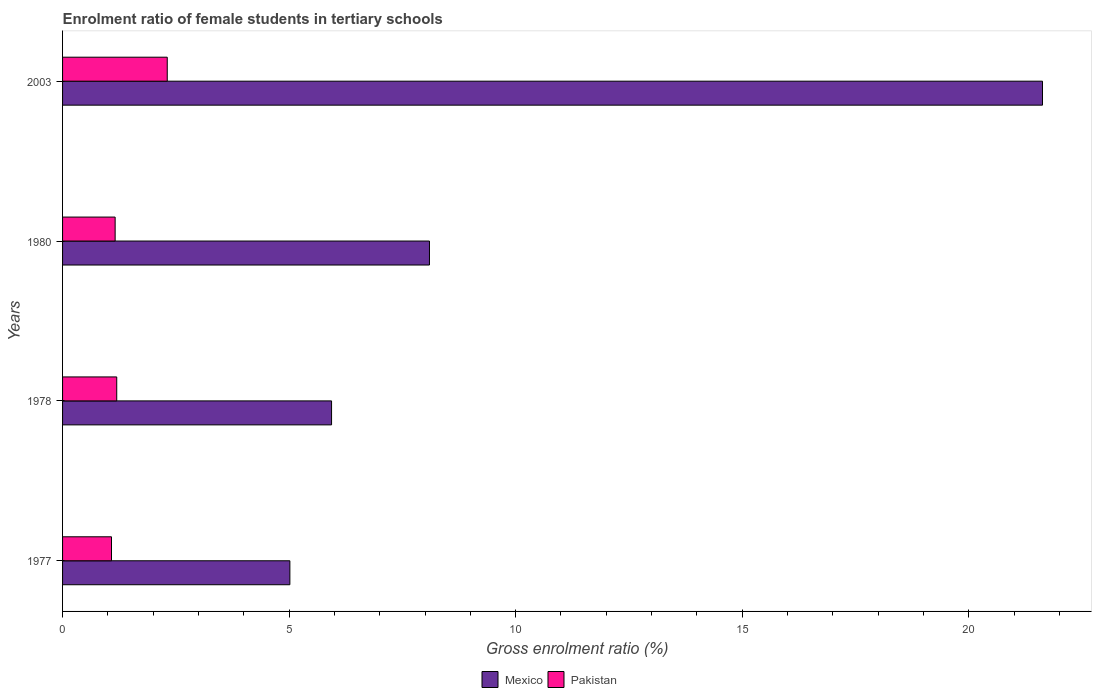How many different coloured bars are there?
Your response must be concise. 2. Are the number of bars per tick equal to the number of legend labels?
Offer a very short reply. Yes. How many bars are there on the 2nd tick from the top?
Make the answer very short. 2. How many bars are there on the 4th tick from the bottom?
Ensure brevity in your answer.  2. What is the label of the 3rd group of bars from the top?
Your response must be concise. 1978. In how many cases, is the number of bars for a given year not equal to the number of legend labels?
Your answer should be compact. 0. What is the enrolment ratio of female students in tertiary schools in Pakistan in 1978?
Make the answer very short. 1.2. Across all years, what is the maximum enrolment ratio of female students in tertiary schools in Mexico?
Make the answer very short. 21.63. What is the total enrolment ratio of female students in tertiary schools in Mexico in the graph?
Give a very brief answer. 40.68. What is the difference between the enrolment ratio of female students in tertiary schools in Pakistan in 1977 and that in 1980?
Your answer should be very brief. -0.08. What is the difference between the enrolment ratio of female students in tertiary schools in Pakistan in 1980 and the enrolment ratio of female students in tertiary schools in Mexico in 2003?
Offer a terse response. -20.47. What is the average enrolment ratio of female students in tertiary schools in Pakistan per year?
Provide a succinct answer. 1.44. In the year 2003, what is the difference between the enrolment ratio of female students in tertiary schools in Pakistan and enrolment ratio of female students in tertiary schools in Mexico?
Offer a very short reply. -19.32. What is the ratio of the enrolment ratio of female students in tertiary schools in Pakistan in 1980 to that in 2003?
Keep it short and to the point. 0.5. What is the difference between the highest and the second highest enrolment ratio of female students in tertiary schools in Mexico?
Offer a terse response. 13.53. What is the difference between the highest and the lowest enrolment ratio of female students in tertiary schools in Pakistan?
Your answer should be compact. 1.23. In how many years, is the enrolment ratio of female students in tertiary schools in Mexico greater than the average enrolment ratio of female students in tertiary schools in Mexico taken over all years?
Give a very brief answer. 1. Is the sum of the enrolment ratio of female students in tertiary schools in Pakistan in 1977 and 1980 greater than the maximum enrolment ratio of female students in tertiary schools in Mexico across all years?
Ensure brevity in your answer.  No. What does the 2nd bar from the top in 1978 represents?
Give a very brief answer. Mexico. What does the 2nd bar from the bottom in 1977 represents?
Your response must be concise. Pakistan. How many bars are there?
Provide a short and direct response. 8. How many years are there in the graph?
Make the answer very short. 4. What is the difference between two consecutive major ticks on the X-axis?
Give a very brief answer. 5. Are the values on the major ticks of X-axis written in scientific E-notation?
Your answer should be very brief. No. Does the graph contain any zero values?
Ensure brevity in your answer.  No. Where does the legend appear in the graph?
Keep it short and to the point. Bottom center. How many legend labels are there?
Your answer should be very brief. 2. How are the legend labels stacked?
Give a very brief answer. Horizontal. What is the title of the graph?
Your answer should be very brief. Enrolment ratio of female students in tertiary schools. What is the label or title of the Y-axis?
Your response must be concise. Years. What is the Gross enrolment ratio (%) in Mexico in 1977?
Provide a short and direct response. 5.02. What is the Gross enrolment ratio (%) in Mexico in 1978?
Ensure brevity in your answer.  5.94. What is the Gross enrolment ratio (%) of Pakistan in 1978?
Your response must be concise. 1.2. What is the Gross enrolment ratio (%) of Mexico in 1980?
Your answer should be very brief. 8.1. What is the Gross enrolment ratio (%) of Pakistan in 1980?
Give a very brief answer. 1.16. What is the Gross enrolment ratio (%) in Mexico in 2003?
Your response must be concise. 21.63. What is the Gross enrolment ratio (%) in Pakistan in 2003?
Your answer should be very brief. 2.31. Across all years, what is the maximum Gross enrolment ratio (%) of Mexico?
Your answer should be compact. 21.63. Across all years, what is the maximum Gross enrolment ratio (%) in Pakistan?
Offer a terse response. 2.31. Across all years, what is the minimum Gross enrolment ratio (%) in Mexico?
Give a very brief answer. 5.02. What is the total Gross enrolment ratio (%) of Mexico in the graph?
Offer a very short reply. 40.68. What is the total Gross enrolment ratio (%) of Pakistan in the graph?
Ensure brevity in your answer.  5.75. What is the difference between the Gross enrolment ratio (%) in Mexico in 1977 and that in 1978?
Make the answer very short. -0.92. What is the difference between the Gross enrolment ratio (%) of Pakistan in 1977 and that in 1978?
Keep it short and to the point. -0.12. What is the difference between the Gross enrolment ratio (%) of Mexico in 1977 and that in 1980?
Keep it short and to the point. -3.08. What is the difference between the Gross enrolment ratio (%) in Pakistan in 1977 and that in 1980?
Offer a terse response. -0.08. What is the difference between the Gross enrolment ratio (%) in Mexico in 1977 and that in 2003?
Ensure brevity in your answer.  -16.61. What is the difference between the Gross enrolment ratio (%) in Pakistan in 1977 and that in 2003?
Your answer should be very brief. -1.23. What is the difference between the Gross enrolment ratio (%) of Mexico in 1978 and that in 1980?
Offer a very short reply. -2.16. What is the difference between the Gross enrolment ratio (%) of Pakistan in 1978 and that in 1980?
Provide a succinct answer. 0.04. What is the difference between the Gross enrolment ratio (%) in Mexico in 1978 and that in 2003?
Provide a succinct answer. -15.69. What is the difference between the Gross enrolment ratio (%) in Pakistan in 1978 and that in 2003?
Your answer should be compact. -1.11. What is the difference between the Gross enrolment ratio (%) of Mexico in 1980 and that in 2003?
Keep it short and to the point. -13.53. What is the difference between the Gross enrolment ratio (%) of Pakistan in 1980 and that in 2003?
Keep it short and to the point. -1.15. What is the difference between the Gross enrolment ratio (%) of Mexico in 1977 and the Gross enrolment ratio (%) of Pakistan in 1978?
Offer a terse response. 3.82. What is the difference between the Gross enrolment ratio (%) in Mexico in 1977 and the Gross enrolment ratio (%) in Pakistan in 1980?
Provide a short and direct response. 3.86. What is the difference between the Gross enrolment ratio (%) of Mexico in 1977 and the Gross enrolment ratio (%) of Pakistan in 2003?
Offer a terse response. 2.71. What is the difference between the Gross enrolment ratio (%) in Mexico in 1978 and the Gross enrolment ratio (%) in Pakistan in 1980?
Ensure brevity in your answer.  4.78. What is the difference between the Gross enrolment ratio (%) in Mexico in 1978 and the Gross enrolment ratio (%) in Pakistan in 2003?
Give a very brief answer. 3.63. What is the difference between the Gross enrolment ratio (%) of Mexico in 1980 and the Gross enrolment ratio (%) of Pakistan in 2003?
Offer a terse response. 5.79. What is the average Gross enrolment ratio (%) in Mexico per year?
Provide a short and direct response. 10.17. What is the average Gross enrolment ratio (%) of Pakistan per year?
Your answer should be compact. 1.44. In the year 1977, what is the difference between the Gross enrolment ratio (%) in Mexico and Gross enrolment ratio (%) in Pakistan?
Your response must be concise. 3.94. In the year 1978, what is the difference between the Gross enrolment ratio (%) in Mexico and Gross enrolment ratio (%) in Pakistan?
Offer a terse response. 4.74. In the year 1980, what is the difference between the Gross enrolment ratio (%) of Mexico and Gross enrolment ratio (%) of Pakistan?
Your response must be concise. 6.94. In the year 2003, what is the difference between the Gross enrolment ratio (%) in Mexico and Gross enrolment ratio (%) in Pakistan?
Give a very brief answer. 19.32. What is the ratio of the Gross enrolment ratio (%) of Mexico in 1977 to that in 1978?
Ensure brevity in your answer.  0.85. What is the ratio of the Gross enrolment ratio (%) in Pakistan in 1977 to that in 1978?
Give a very brief answer. 0.9. What is the ratio of the Gross enrolment ratio (%) in Mexico in 1977 to that in 1980?
Your response must be concise. 0.62. What is the ratio of the Gross enrolment ratio (%) in Pakistan in 1977 to that in 1980?
Keep it short and to the point. 0.93. What is the ratio of the Gross enrolment ratio (%) in Mexico in 1977 to that in 2003?
Offer a very short reply. 0.23. What is the ratio of the Gross enrolment ratio (%) in Pakistan in 1977 to that in 2003?
Provide a succinct answer. 0.47. What is the ratio of the Gross enrolment ratio (%) of Mexico in 1978 to that in 1980?
Ensure brevity in your answer.  0.73. What is the ratio of the Gross enrolment ratio (%) in Pakistan in 1978 to that in 1980?
Your answer should be very brief. 1.03. What is the ratio of the Gross enrolment ratio (%) of Mexico in 1978 to that in 2003?
Offer a very short reply. 0.27. What is the ratio of the Gross enrolment ratio (%) of Pakistan in 1978 to that in 2003?
Keep it short and to the point. 0.52. What is the ratio of the Gross enrolment ratio (%) in Mexico in 1980 to that in 2003?
Provide a succinct answer. 0.37. What is the ratio of the Gross enrolment ratio (%) of Pakistan in 1980 to that in 2003?
Keep it short and to the point. 0.5. What is the difference between the highest and the second highest Gross enrolment ratio (%) of Mexico?
Offer a terse response. 13.53. What is the difference between the highest and the second highest Gross enrolment ratio (%) in Pakistan?
Your answer should be very brief. 1.11. What is the difference between the highest and the lowest Gross enrolment ratio (%) of Mexico?
Your answer should be compact. 16.61. What is the difference between the highest and the lowest Gross enrolment ratio (%) in Pakistan?
Offer a very short reply. 1.23. 